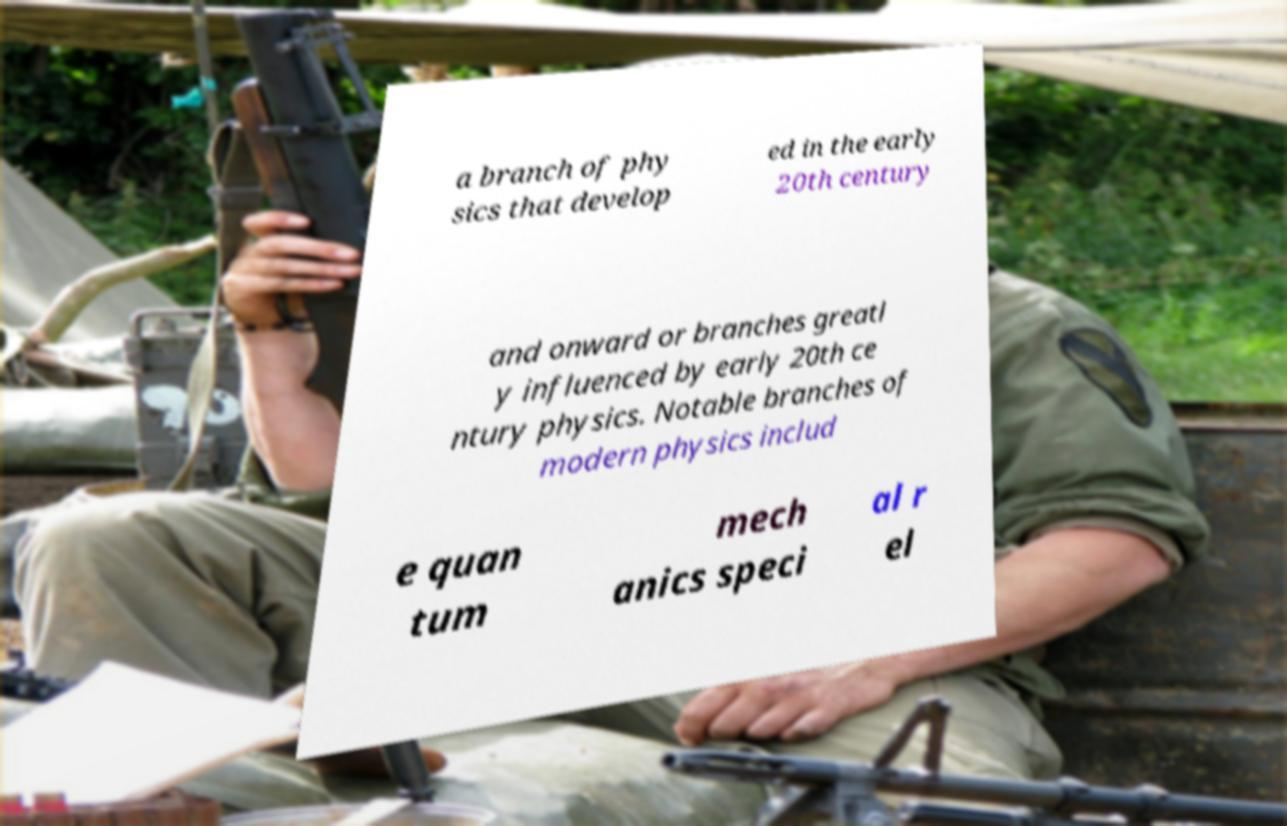Please identify and transcribe the text found in this image. a branch of phy sics that develop ed in the early 20th century and onward or branches greatl y influenced by early 20th ce ntury physics. Notable branches of modern physics includ e quan tum mech anics speci al r el 